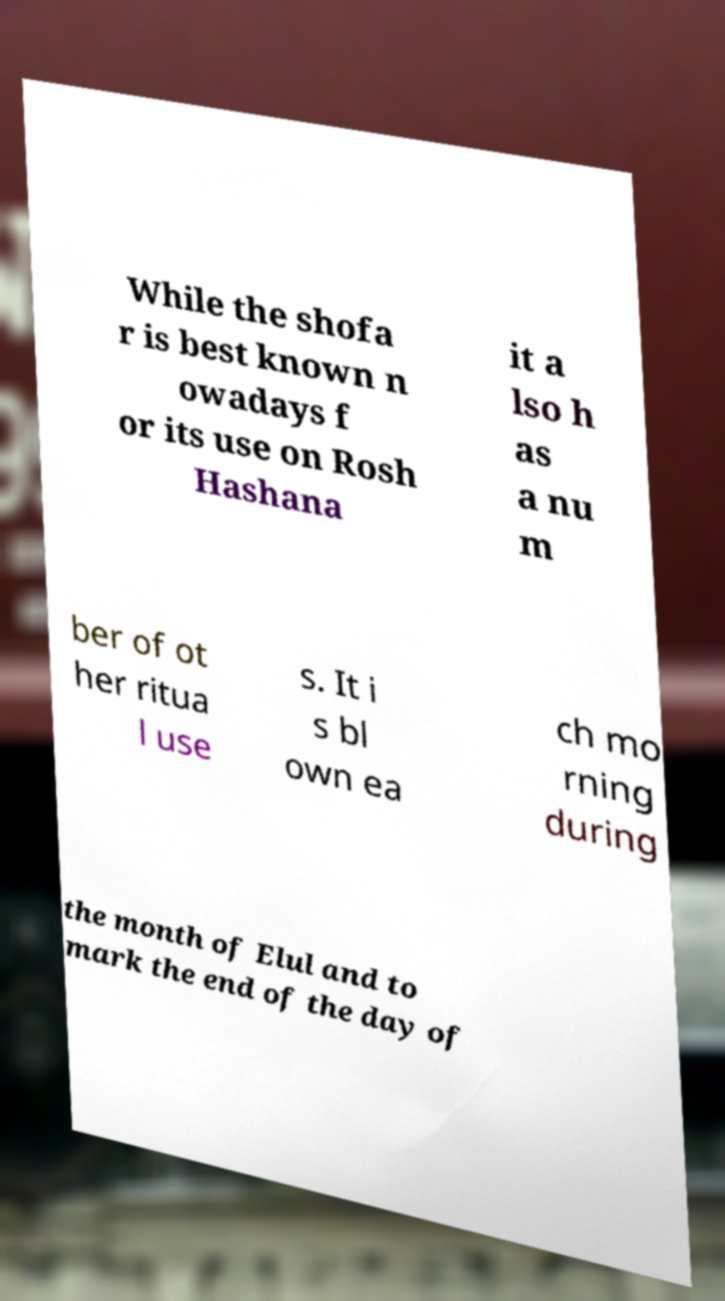Can you accurately transcribe the text from the provided image for me? While the shofa r is best known n owadays f or its use on Rosh Hashana it a lso h as a nu m ber of ot her ritua l use s. It i s bl own ea ch mo rning during the month of Elul and to mark the end of the day of 